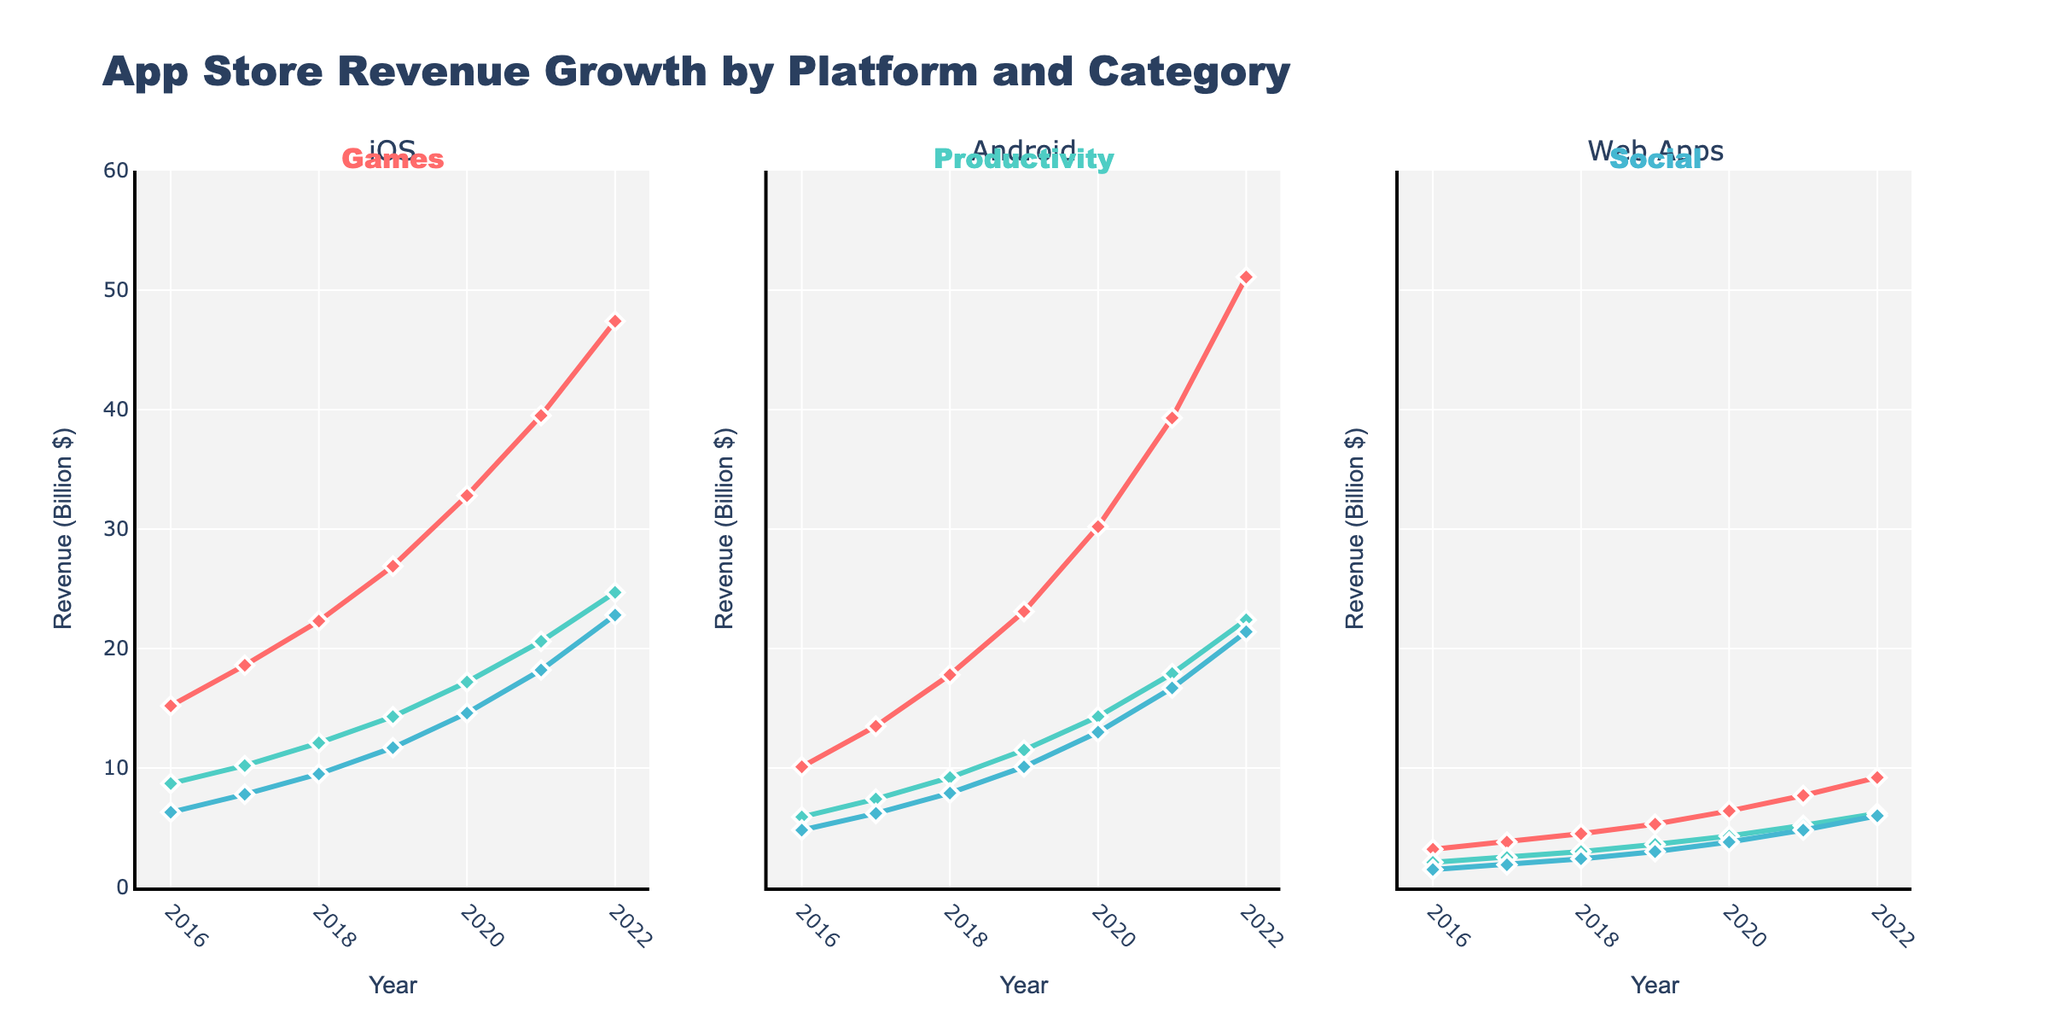What was the total revenue for iOS Games and Android Games in 2018? First, locate the revenue values for iOS Games (22.3 Billion $) and Android Games (17.8 Billion $) in 2018. Then, sum these values: 22.3 + 17.8 = 40.1 Billion $.
Answer: 40.1 Billion $ Which app category saw the highest revenue growth for Web Apps from 2016 to 2022? Check the revenue for all categories in 2016 and compare it with 2022. Web Apps Games increased from 3.2B to 9.2B, Productivity from 2.1B to 6.2B, and Social from 1.5B to 6.0B. The highest growth is in Games (9.2B - 3.2B = 6B growth).
Answer: Games Between 2021 and 2022, which platform saw the highest increase in revenue for Social category apps? Find the revenue for Social category apps in 2021 and 2022 for all platforms. iOS increased from 18.2B to 22.8B (+4.6B), Android from 16.7B to 21.4B (+4.7B), and Web Apps from 4.8B to 6.0B (+1.2B). The highest increase is in Android (+4.7B).
Answer: Android Compare the trend of iOS Productivity and Web Apps Productivity from 2016 to 2022. Which one showed a steeper increase? Observe the revenue lines for iOS Productivity and Web Apps Productivity from start to end. iOS rose from 8.7B to 24.7B, a growth of 16B. Web Apps rose from 2.1B to 6.2B, a growth of 4.1B. Thus, iOS showed a steeper increase.
Answer: iOS Which platform had the least revenue for the Productivity category in 2020? Look at the revenue values for Productivity in 2020: iOS (17.2B), Android (14.3B), and Web Apps (4.3B). The least revenue was in Web Apps.
Answer: Web Apps What was the average revenue for Android Social apps from 2016 to 2022? Sum the yearly revenues for Android Social from 2016 to 2022 (4.8 + 6.2 + 7.9 + 10.1 + 13.0 + 16.7 + 21.4) and divide by 7. This is (4.8 + 6.2 + 7.9 + 10.1 + 13.0 + 16.7 + 21.4) / 7 = 11.4 Billion $.
Answer: 11.4 Billion $ Which category under iOS showed the highest revenue in 2022? Refer to the revenue values for each iOS category in 2022: Games (47.4 Billion $), Productivity (24.7 Billion $), Social (22.8 Billion $). Highest revenue was in Games.
Answer: Games 